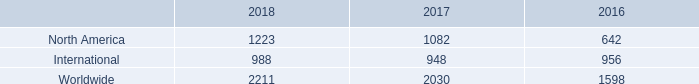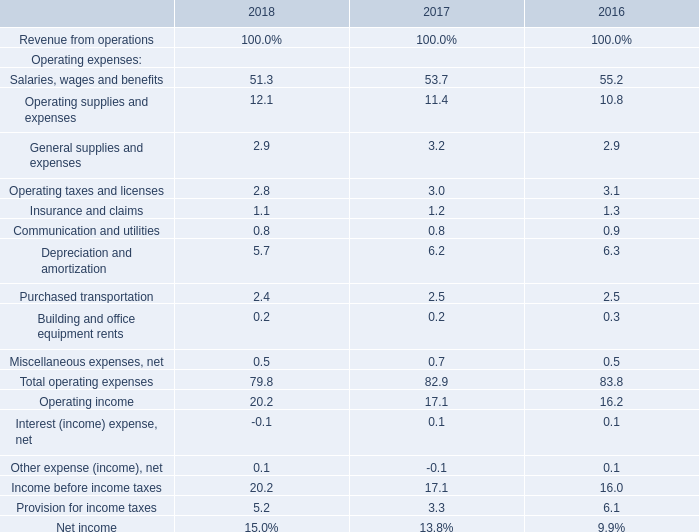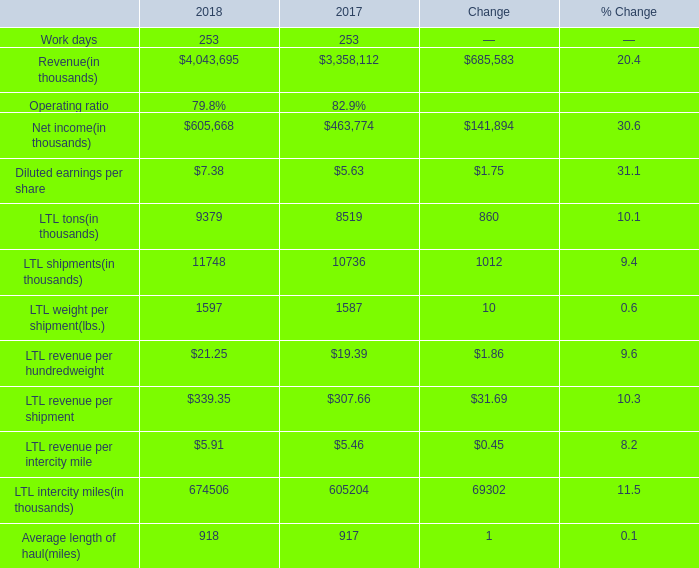In the year with lowest amount of Net income, what's the increasing rate of LTL tons? 
Computations: ((9379 - 8519) / 8519)
Answer: 0.10095. 